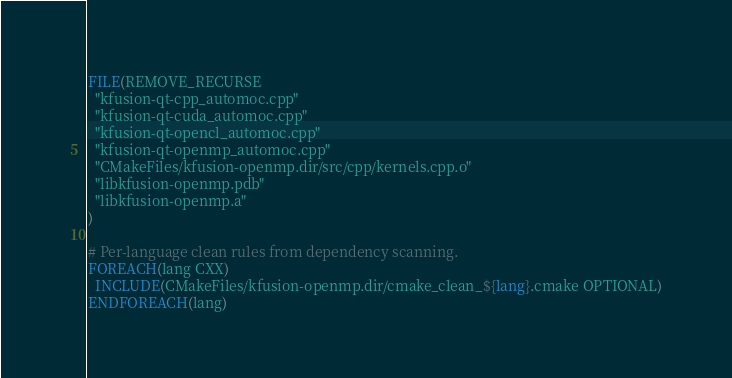Convert code to text. <code><loc_0><loc_0><loc_500><loc_500><_CMake_>FILE(REMOVE_RECURSE
  "kfusion-qt-cpp_automoc.cpp"
  "kfusion-qt-cuda_automoc.cpp"
  "kfusion-qt-opencl_automoc.cpp"
  "kfusion-qt-openmp_automoc.cpp"
  "CMakeFiles/kfusion-openmp.dir/src/cpp/kernels.cpp.o"
  "libkfusion-openmp.pdb"
  "libkfusion-openmp.a"
)

# Per-language clean rules from dependency scanning.
FOREACH(lang CXX)
  INCLUDE(CMakeFiles/kfusion-openmp.dir/cmake_clean_${lang}.cmake OPTIONAL)
ENDFOREACH(lang)
</code> 